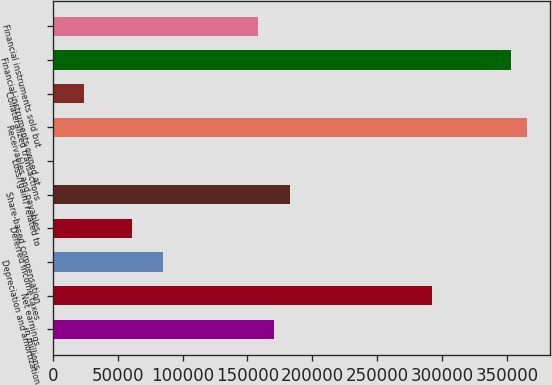Convert chart to OTSL. <chart><loc_0><loc_0><loc_500><loc_500><bar_chart><fcel>in millions<fcel>Net earnings<fcel>Depreciation and amortization<fcel>Deferred income taxes<fcel>Share-based compensation<fcel>Loss/(gain) related to<fcel>Receivables and payables<fcel>Collateralized transactions<fcel>Financial instruments owned at<fcel>Financial instruments sold but<nl><fcel>170394<fcel>292102<fcel>85198.6<fcel>60857<fcel>182565<fcel>3<fcel>365127<fcel>24344.6<fcel>352956<fcel>158223<nl></chart> 